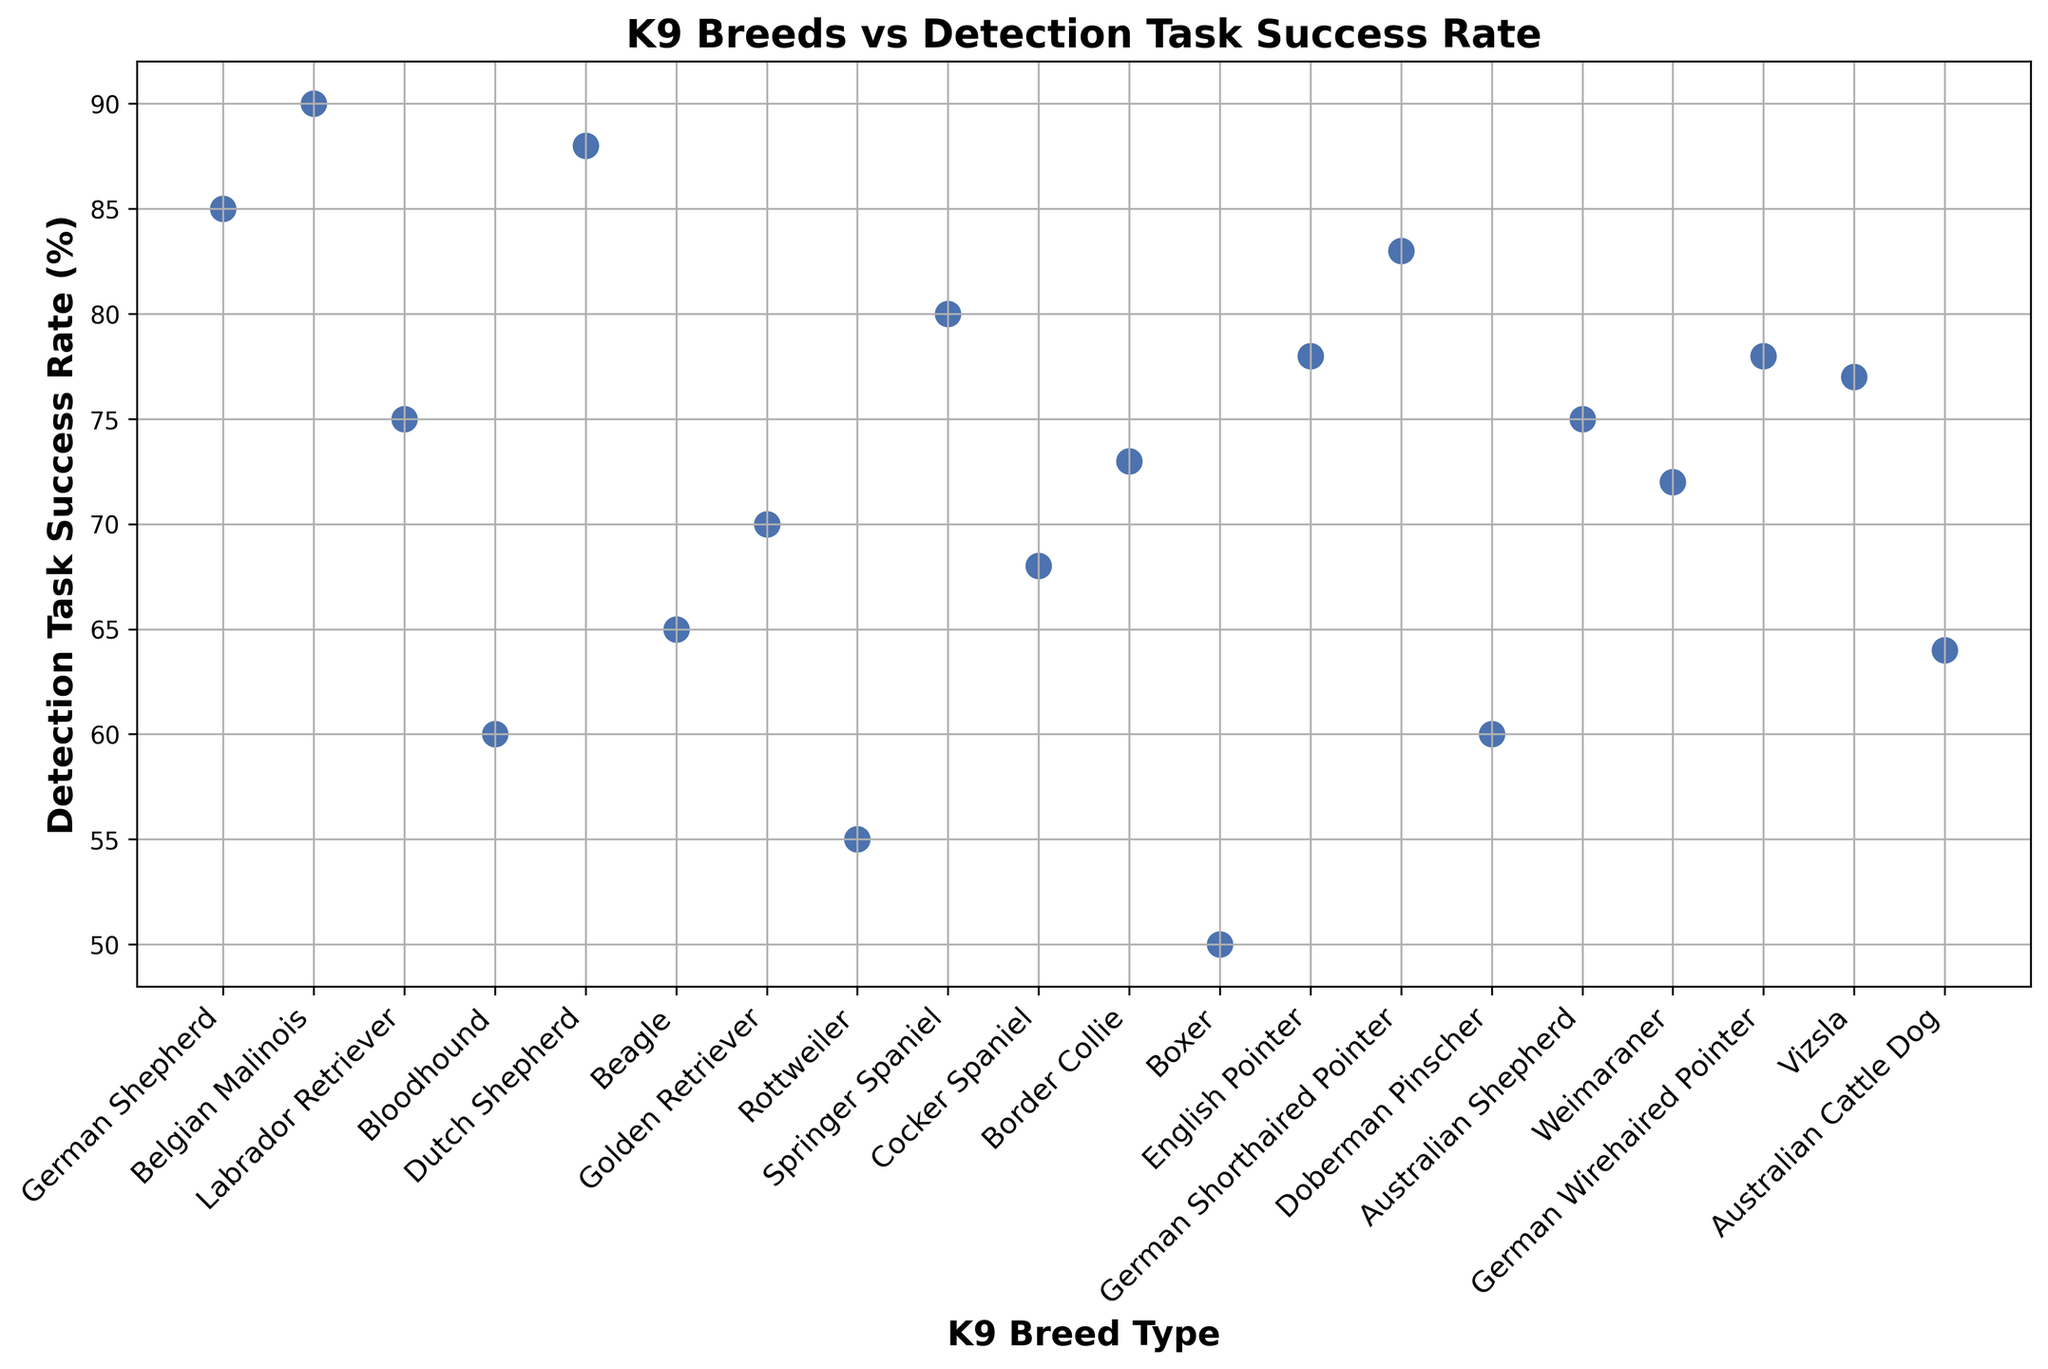Which K9 breed has the highest Detection Task Success Rate? To determine the breed with the highest success rate, look for the highest point on the y-axis. The German Shepherd and Belgian Malinois appear to have the highest positioning, but upon close inspection, Belgian Malinois slightly surpasses German Shepherd.
Answer: Belgian Malinois Which K9 breed has the lowest Detection Task Success Rate? To find the breed with the lowest success rate, look for the point positioned lowest on the y-axis. The lowest point corresponds to the Boxer breed.
Answer: Boxer How does the Detection Task Success Rate of a German Shepherd compare to that of a Labrador Retriever? Compare the y-axis values for each breed. German Shepherd has a success rate of 85%, whereas Labrador Retriever has a success rate of 75%. German Shepherd has a higher success rate.
Answer: German Shepherd has a higher success rate What is the average Detection Task Success Rate of all the K9 breeds? Sum all the success rates and divide by the number of breeds. The sum is (85 + 90 + 75 + 60 + 88 + 65 + 70 + 55 + 80 + 68 + 73 + 50 + 78 + 83 + 60 + 75 + 72 + 78 + 77 + 64) = 1,496. There are 20 breeds, so the average is 1,496 / 20 = 74.8.
Answer: 74.8 Between Beagle and Golden Retriever, which K9 breed has a higher success rate? Compare the Detection Task Success Rate for Beagle and Golden Retriever. The Beagle has a success rate of 65%, while the Golden Retriever has a success rate of 70%. Golden Retriever has a higher success rate.
Answer: Golden Retriever Is the Detection Task Success Rate for Australian Shepherd above or below the median Detection Task Success Rate of all breeds? First, find the median by arranging all success rates in ascending order and finding the middle value(s). The median is the average of the 10th and 11th values in the sorted list {50, 55, 60, 60, 64, 65, 68, 70, 72, 73, 75, 75, 77, 78, 78, 80, 83, 85, 88, 90}, which are 73 and 75. Hence, the median is (73 + 75) / 2 = 74. The Australian Shepherd has a success rate of 75%, which is above the median of 74.
Answer: Above What is the difference in Detection Task Success Rates between the highest and lowest performing K9 breeds? Find the difference between the highest value (Belgian Malinois: 90%) and the lowest value (Boxer: 50%). The difference is 90 - 50 = 40.
Answer: 40 How many K9 breeds have a Detection Task Success Rate above 80%? Count the breeds with a success rate greater than 80%. The breeds are German Shepherd (85%), Belgian Malinois (90%), Dutch Shepherd (88%), German Shorthaired Pointer (83%). There are 4 breeds in total.
Answer: 4 What is the sum of Detection Task Success Rates for Springer Spaniel and English Pointer? Add the success rates of Springer Spaniel (80%) and English Pointer (78%). The sum is 80 + 78 = 158.
Answer: 158 